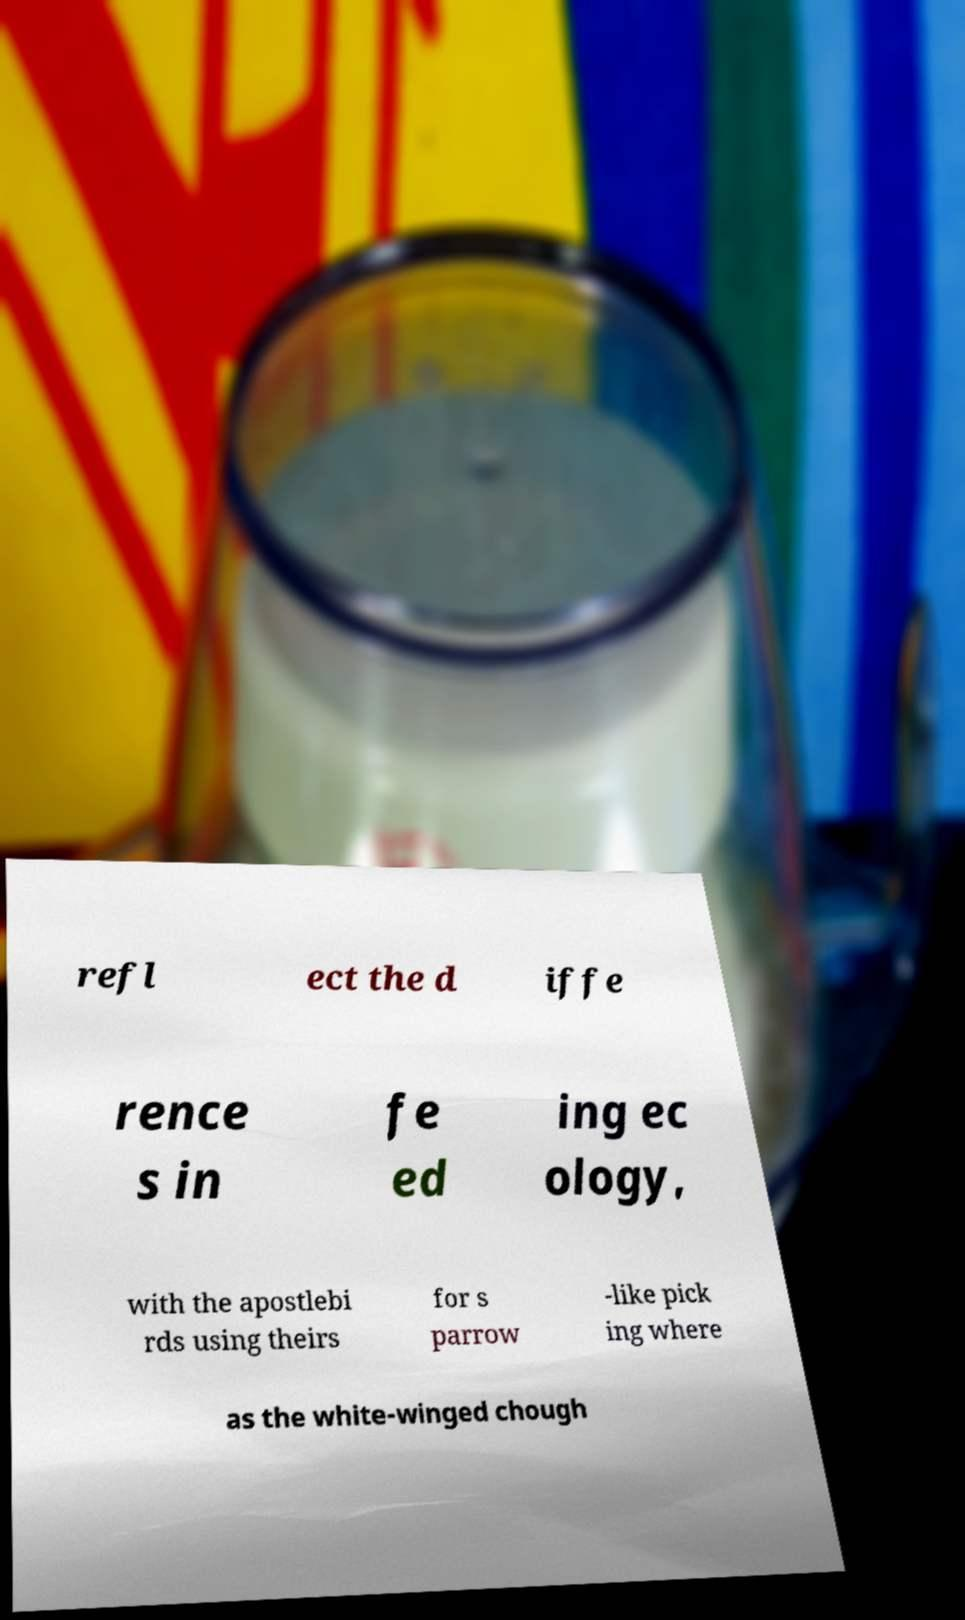Can you read and provide the text displayed in the image?This photo seems to have some interesting text. Can you extract and type it out for me? refl ect the d iffe rence s in fe ed ing ec ology, with the apostlebi rds using theirs for s parrow -like pick ing where as the white-winged chough 